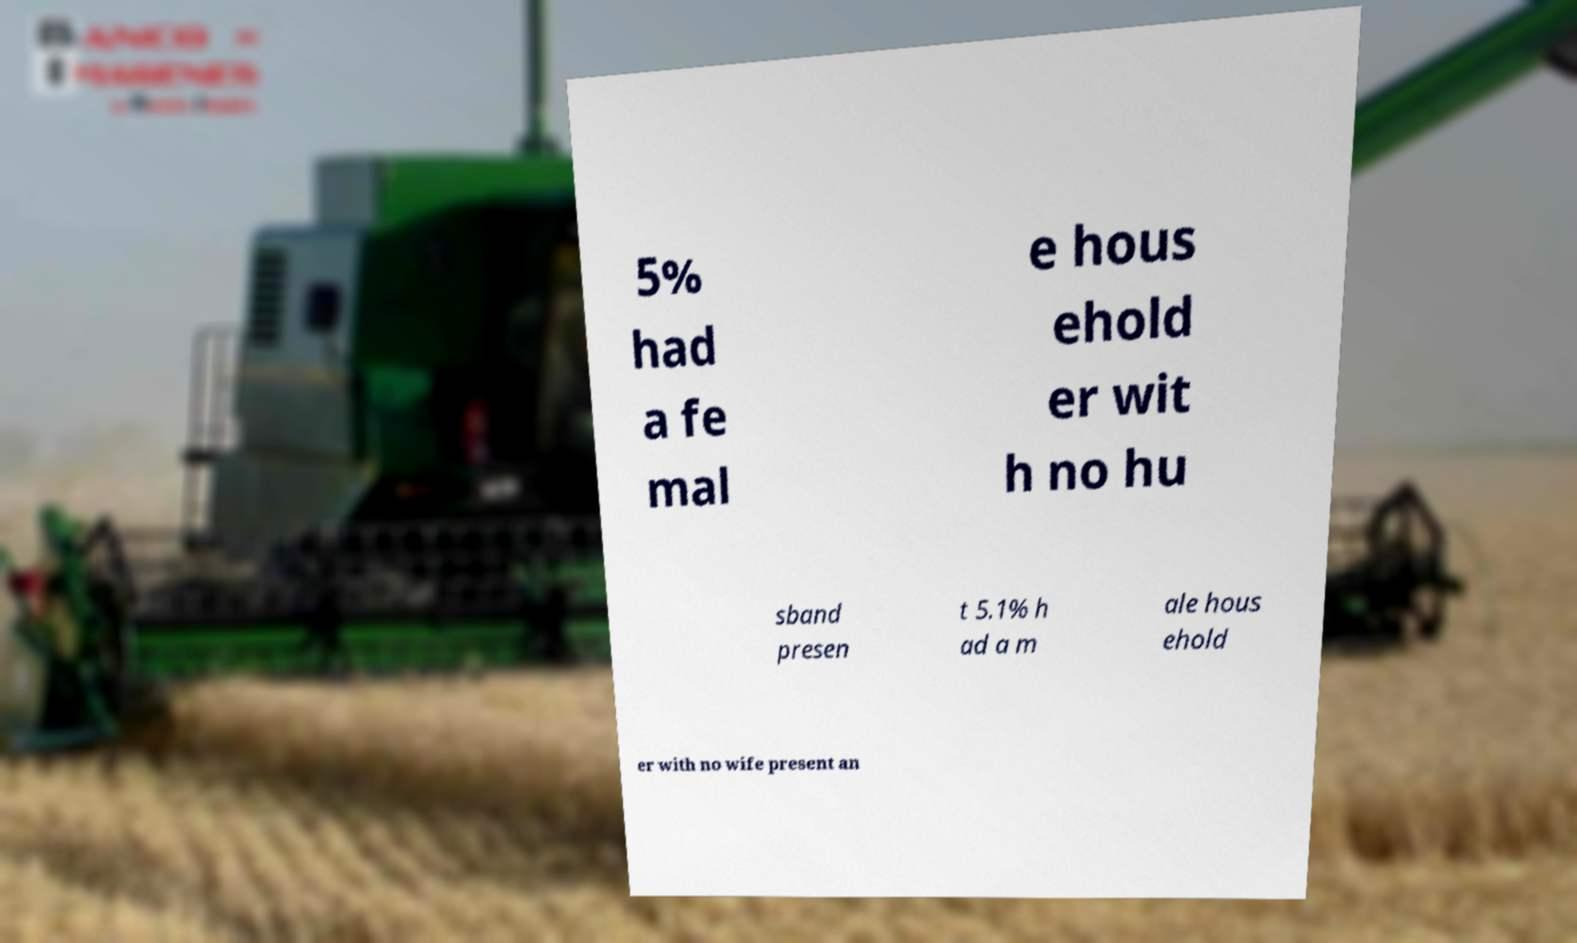I need the written content from this picture converted into text. Can you do that? 5% had a fe mal e hous ehold er wit h no hu sband presen t 5.1% h ad a m ale hous ehold er with no wife present an 